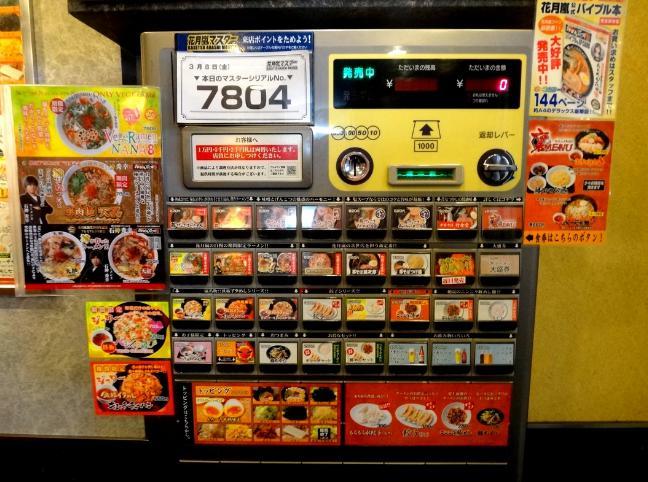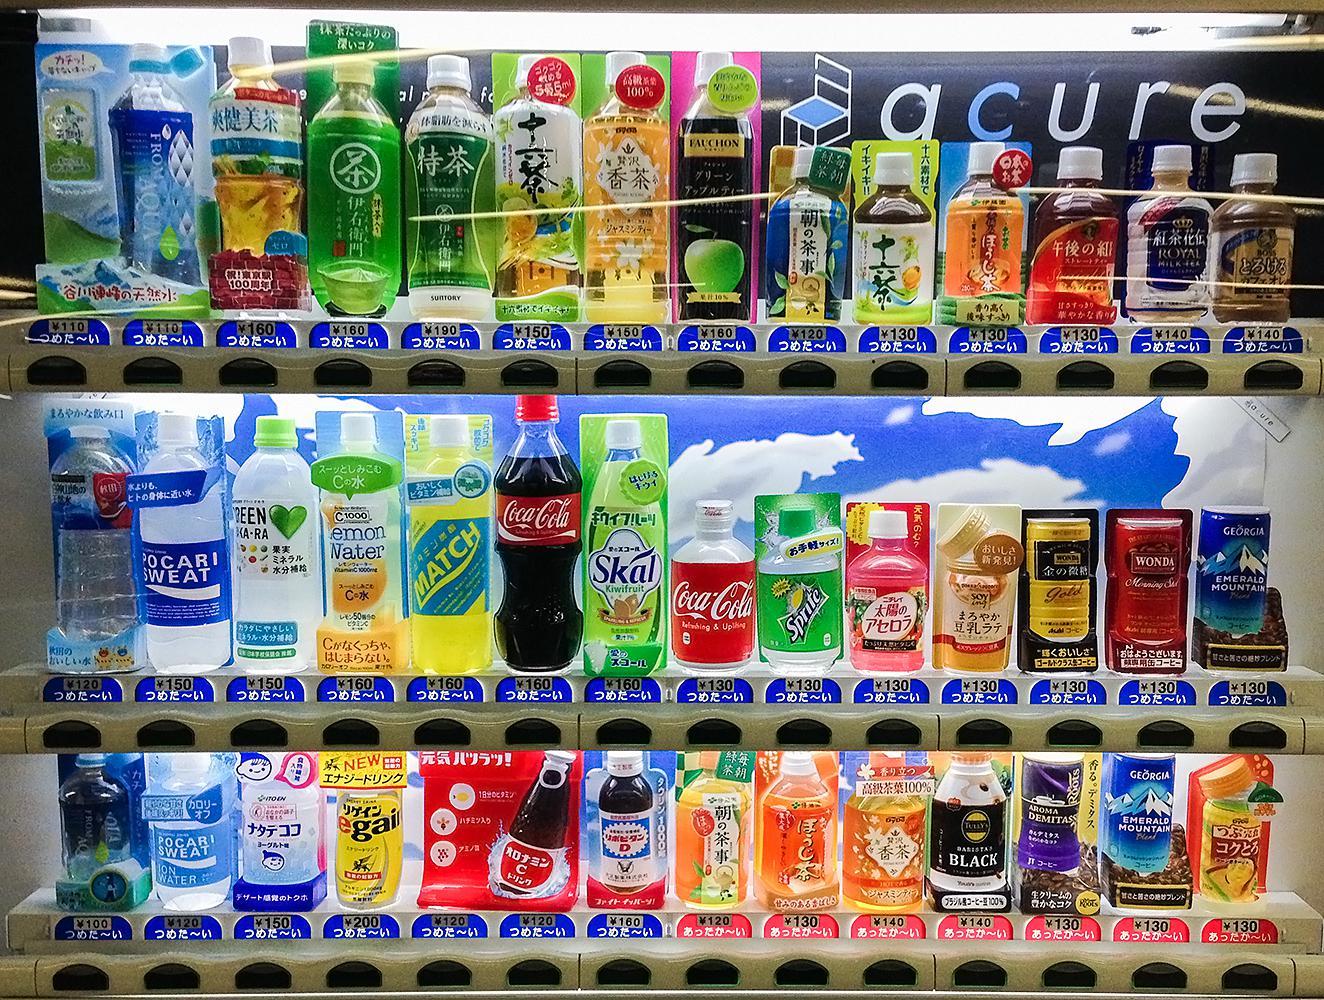The first image is the image on the left, the second image is the image on the right. Analyze the images presented: Is the assertion "One machine is cherry red." valid? Answer yes or no. No. The first image is the image on the left, the second image is the image on the right. For the images shown, is this caption "An image shows a single vending machine, which offers meal-type options." true? Answer yes or no. Yes. 